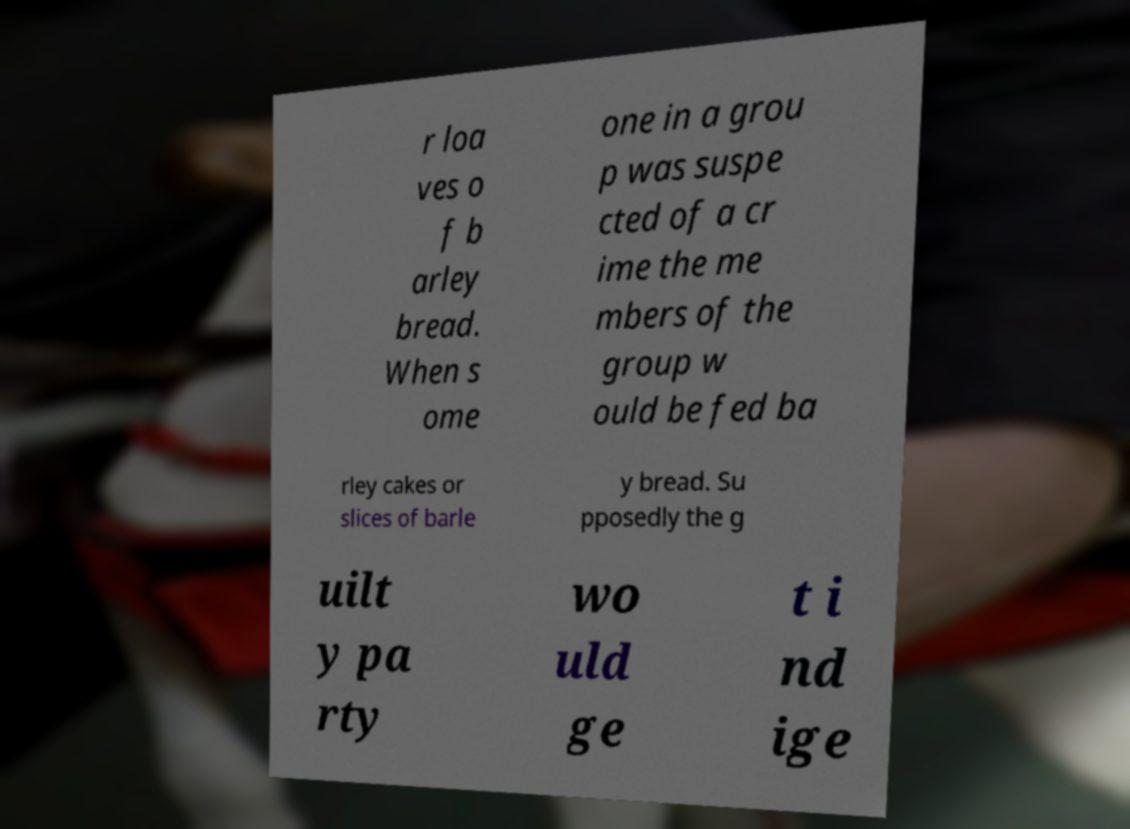I need the written content from this picture converted into text. Can you do that? r loa ves o f b arley bread. When s ome one in a grou p was suspe cted of a cr ime the me mbers of the group w ould be fed ba rley cakes or slices of barle y bread. Su pposedly the g uilt y pa rty wo uld ge t i nd ige 